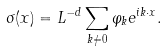<formula> <loc_0><loc_0><loc_500><loc_500>\sigma ( { x } ) = L ^ { - d } \sum _ { { k } \neq { 0 } } \varphi _ { k } e ^ { i { k } \cdot { x } } .</formula> 